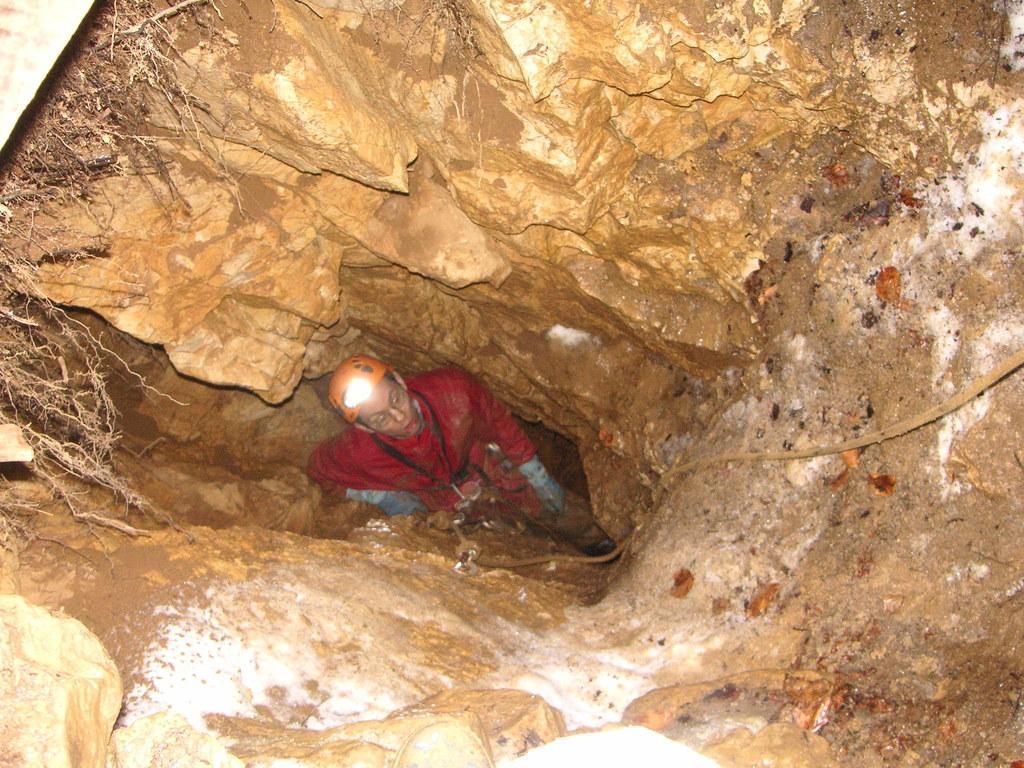Describe this image in one or two sentences. In this image we can see a person digging a small cave. On the left side of the image there are some roots. In the background of the image there are rocks. 